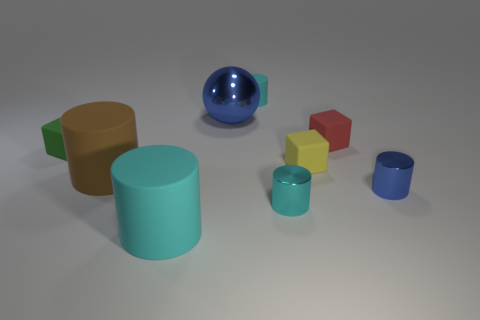There is a metallic object that is the same color as the big ball; what size is it?
Give a very brief answer. Small. What is the shape of the blue object that is behind the large rubber cylinder that is to the left of the large cyan cylinder?
Provide a short and direct response. Sphere. Is there a tiny blue metal thing on the left side of the cube that is left of the cyan cylinder that is behind the big blue metallic sphere?
Your answer should be compact. No. There is a rubber cylinder that is the same size as the green rubber cube; what color is it?
Your answer should be very brief. Cyan. There is a metal object that is both to the left of the small red matte object and to the right of the tiny matte cylinder; what is its shape?
Your answer should be very brief. Cylinder. There is a cyan thing that is on the right side of the rubber cylinder that is right of the big ball; what is its size?
Provide a short and direct response. Small. What number of large cylinders have the same color as the large sphere?
Your answer should be very brief. 0. How many other objects are there of the same size as the blue metal cylinder?
Offer a terse response. 5. There is a block that is both to the right of the green rubber thing and in front of the red rubber object; what size is it?
Your response must be concise. Small. What number of large things are the same shape as the small green rubber thing?
Give a very brief answer. 0. 